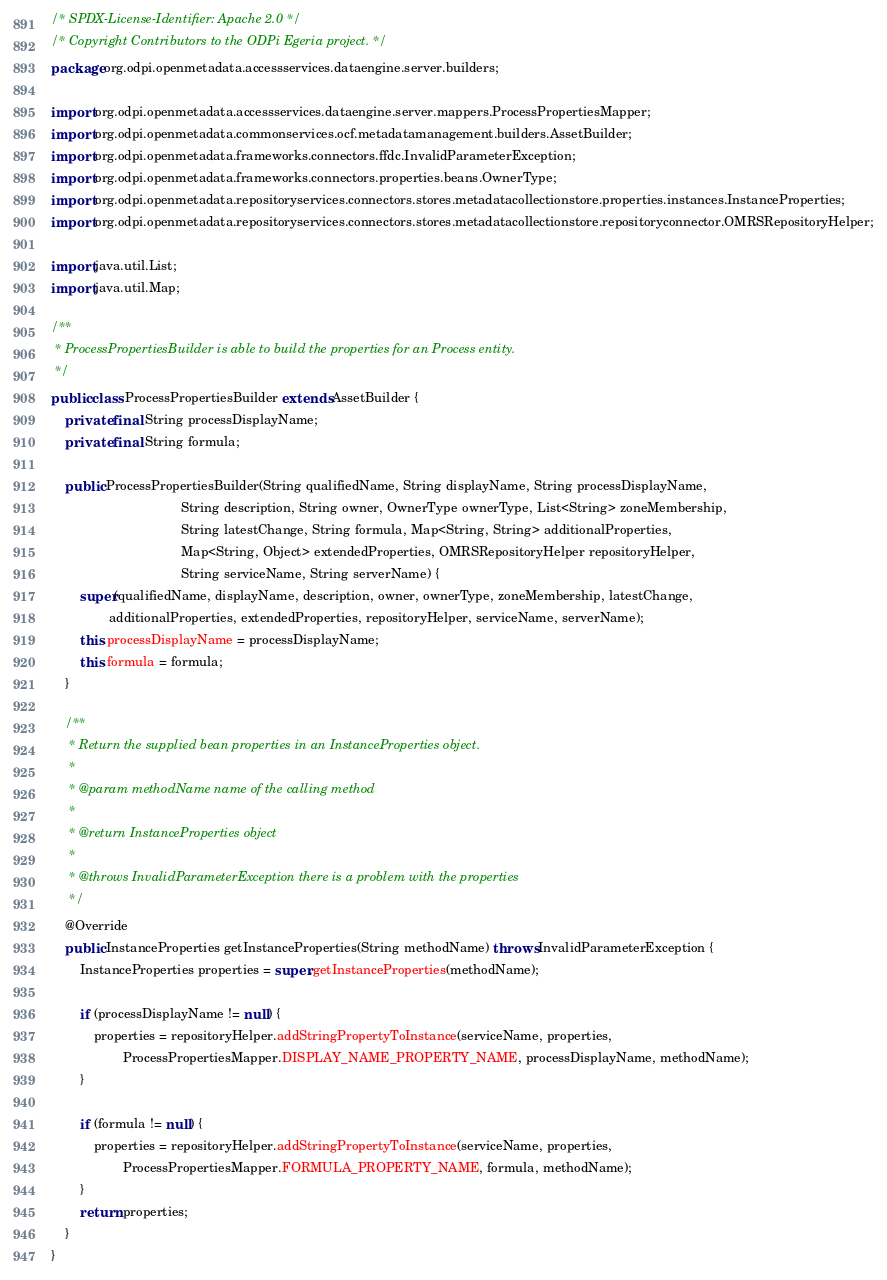<code> <loc_0><loc_0><loc_500><loc_500><_Java_>/* SPDX-License-Identifier: Apache 2.0 */
/* Copyright Contributors to the ODPi Egeria project. */
package org.odpi.openmetadata.accessservices.dataengine.server.builders;

import org.odpi.openmetadata.accessservices.dataengine.server.mappers.ProcessPropertiesMapper;
import org.odpi.openmetadata.commonservices.ocf.metadatamanagement.builders.AssetBuilder;
import org.odpi.openmetadata.frameworks.connectors.ffdc.InvalidParameterException;
import org.odpi.openmetadata.frameworks.connectors.properties.beans.OwnerType;
import org.odpi.openmetadata.repositoryservices.connectors.stores.metadatacollectionstore.properties.instances.InstanceProperties;
import org.odpi.openmetadata.repositoryservices.connectors.stores.metadatacollectionstore.repositoryconnector.OMRSRepositoryHelper;

import java.util.List;
import java.util.Map;

/**
 * ProcessPropertiesBuilder is able to build the properties for an Process entity.
 */
public class ProcessPropertiesBuilder extends AssetBuilder {
    private final String processDisplayName;
    private final String formula;

    public ProcessPropertiesBuilder(String qualifiedName, String displayName, String processDisplayName,
                                    String description, String owner, OwnerType ownerType, List<String> zoneMembership,
                                    String latestChange, String formula, Map<String, String> additionalProperties,
                                    Map<String, Object> extendedProperties, OMRSRepositoryHelper repositoryHelper,
                                    String serviceName, String serverName) {
        super(qualifiedName, displayName, description, owner, ownerType, zoneMembership, latestChange,
                additionalProperties, extendedProperties, repositoryHelper, serviceName, serverName);
        this.processDisplayName = processDisplayName;
        this.formula = formula;
    }

    /**
     * Return the supplied bean properties in an InstanceProperties object.
     *
     * @param methodName name of the calling method
     *
     * @return InstanceProperties object
     *
     * @throws InvalidParameterException there is a problem with the properties
     */
    @Override
    public InstanceProperties getInstanceProperties(String methodName) throws InvalidParameterException {
        InstanceProperties properties = super.getInstanceProperties(methodName);

        if (processDisplayName != null) {
            properties = repositoryHelper.addStringPropertyToInstance(serviceName, properties,
                    ProcessPropertiesMapper.DISPLAY_NAME_PROPERTY_NAME, processDisplayName, methodName);
        }

        if (formula != null) {
            properties = repositoryHelper.addStringPropertyToInstance(serviceName, properties,
                    ProcessPropertiesMapper.FORMULA_PROPERTY_NAME, formula, methodName);
        }
        return properties;
    }
}
</code> 